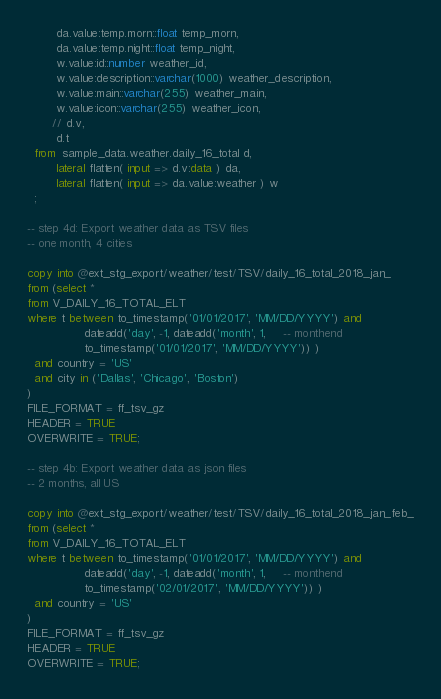<code> <loc_0><loc_0><loc_500><loc_500><_SQL_>        da.value:temp.morn::float temp_morn,
        da.value:temp.night::float temp_night,
        w.value:id::number weather_id,
        w.value:description::varchar(1000) weather_description,
        w.value:main::varchar(255) weather_main,
        w.value:icon::varchar(255) weather_icon,
       // d.v,
        d.t
  from  sample_data.weather.daily_16_total d,
        lateral flatten( input => d.v:data ) da,
        lateral flatten( input => da.value:weather ) w
  ;

-- step 4d: Export weather data as TSV files
-- one month, 4 cities

copy into @ext_stg_export/weather/test/TSV/daily_16_total_2018_jan_
from (select *
from V_DAILY_16_TOTAL_ELT
where t between to_timestamp('01/01/2017', 'MM/DD/YYYY') and
                dateadd('day', -1, dateadd('month', 1,     -- monthend
                to_timestamp('01/01/2017', 'MM/DD/YYYY')) )
  and country = 'US'
  and city in ('Dallas', 'Chicago', 'Boston')
)
FILE_FORMAT = ff_tsv_gz
HEADER = TRUE
OVERWRITE = TRUE;

-- step 4b: Export weather data as json files
-- 2 months, all US

copy into @ext_stg_export/weather/test/TSV/daily_16_total_2018_jan_feb_
from (select *
from V_DAILY_16_TOTAL_ELT
where t between to_timestamp('01/01/2017', 'MM/DD/YYYY') and
                dateadd('day', -1, dateadd('month', 1,     -- monthend
                to_timestamp('02/01/2017', 'MM/DD/YYYY')) )
  and country = 'US'
)
FILE_FORMAT = ff_tsv_gz
HEADER = TRUE
OVERWRITE = TRUE;</code> 